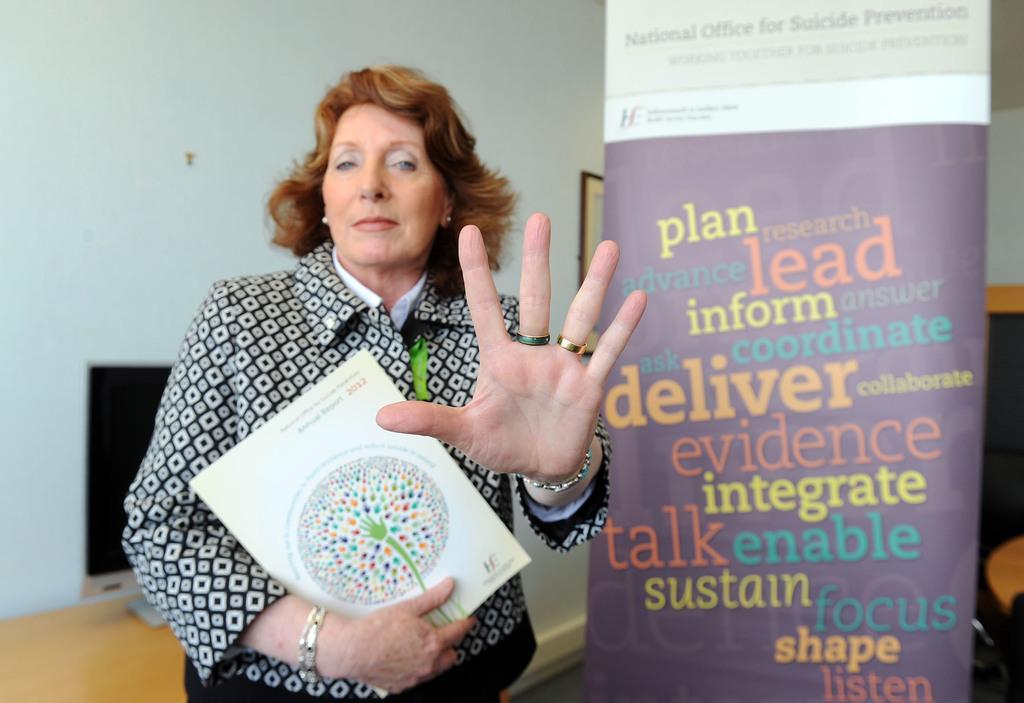Could you give a brief overview of what you see in this image? This picture is clicked inside. In the center there is a person holding an object and standing. On the right we can see the banner on which we can see the text. In the background there is a wall and we can see a monitor placed on the top of the wooden table and there are some objects in the background. 